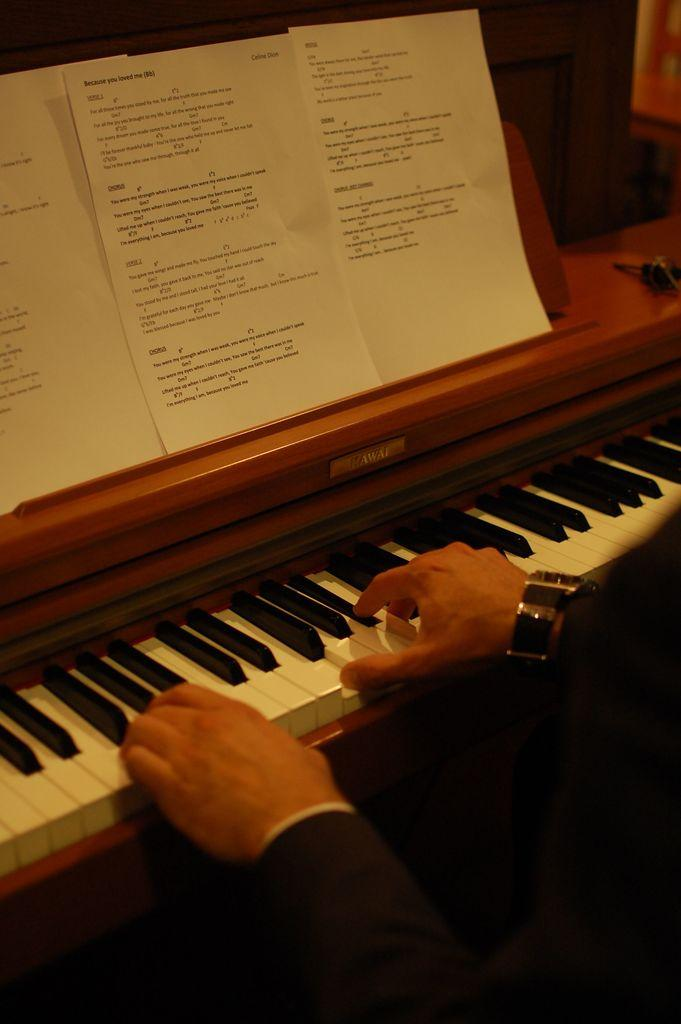What is the person in the image doing? The person is playing piano. What can be seen in front of the person? There are three papers in front of the person. How many snakes are slithering around the person's feet in the image? There are no snakes present in the image. What type of coat is the person wearing in the image? The image does not show the person wearing a coat. 